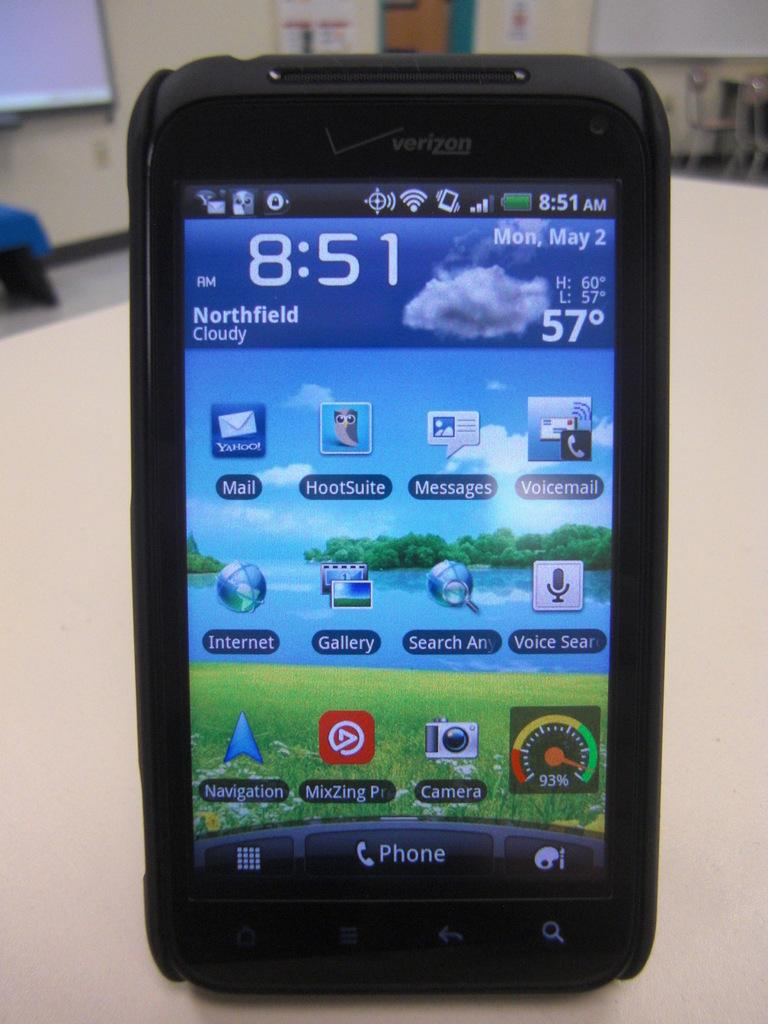<image>
Share a concise interpretation of the image provided. A smart phone displaying Northfield weather at 8:51 